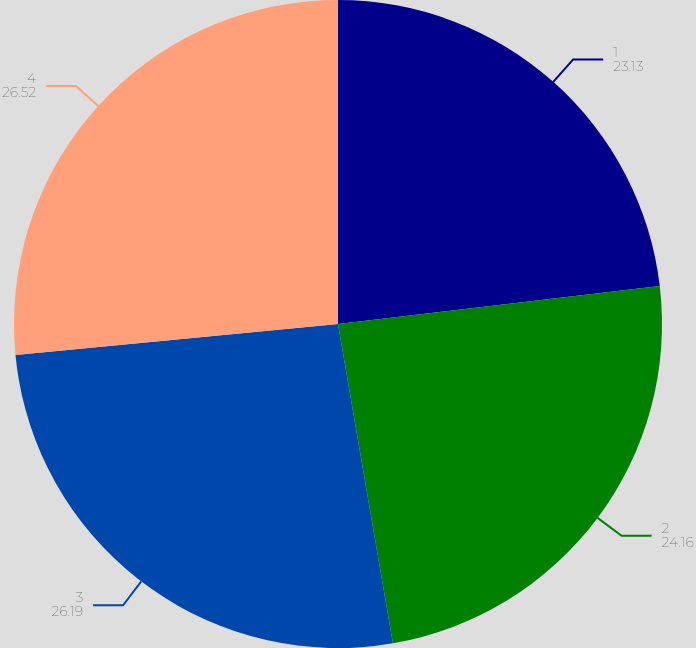Convert chart to OTSL. <chart><loc_0><loc_0><loc_500><loc_500><pie_chart><fcel>1<fcel>2<fcel>3<fcel>4<nl><fcel>23.13%<fcel>24.16%<fcel>26.19%<fcel>26.52%<nl></chart> 